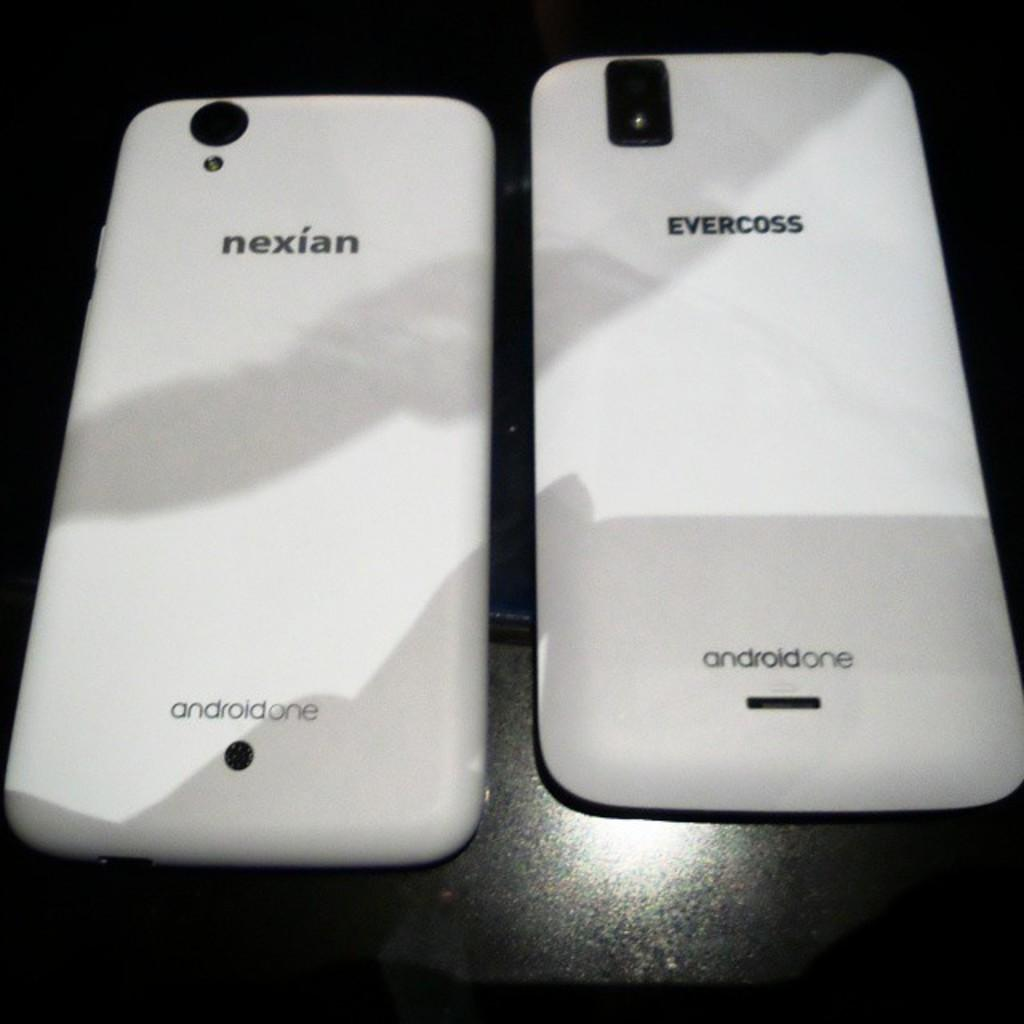<image>
Relay a brief, clear account of the picture shown. The backs of white Nexian and Evercross smartphones next to each other. 